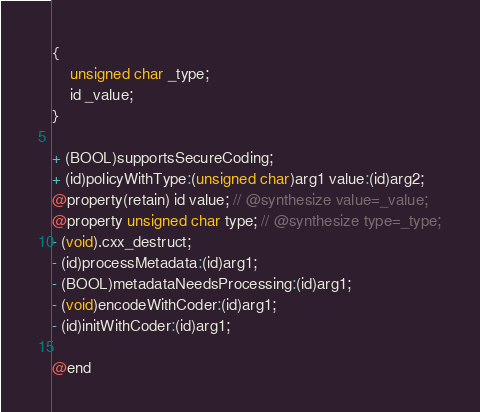<code> <loc_0><loc_0><loc_500><loc_500><_C_>{
    unsigned char _type;
    id _value;
}

+ (BOOL)supportsSecureCoding;
+ (id)policyWithType:(unsigned char)arg1 value:(id)arg2;
@property(retain) id value; // @synthesize value=_value;
@property unsigned char type; // @synthesize type=_type;
- (void).cxx_destruct;
- (id)processMetadata:(id)arg1;
- (BOOL)metadataNeedsProcessing:(id)arg1;
- (void)encodeWithCoder:(id)arg1;
- (id)initWithCoder:(id)arg1;

@end

</code> 